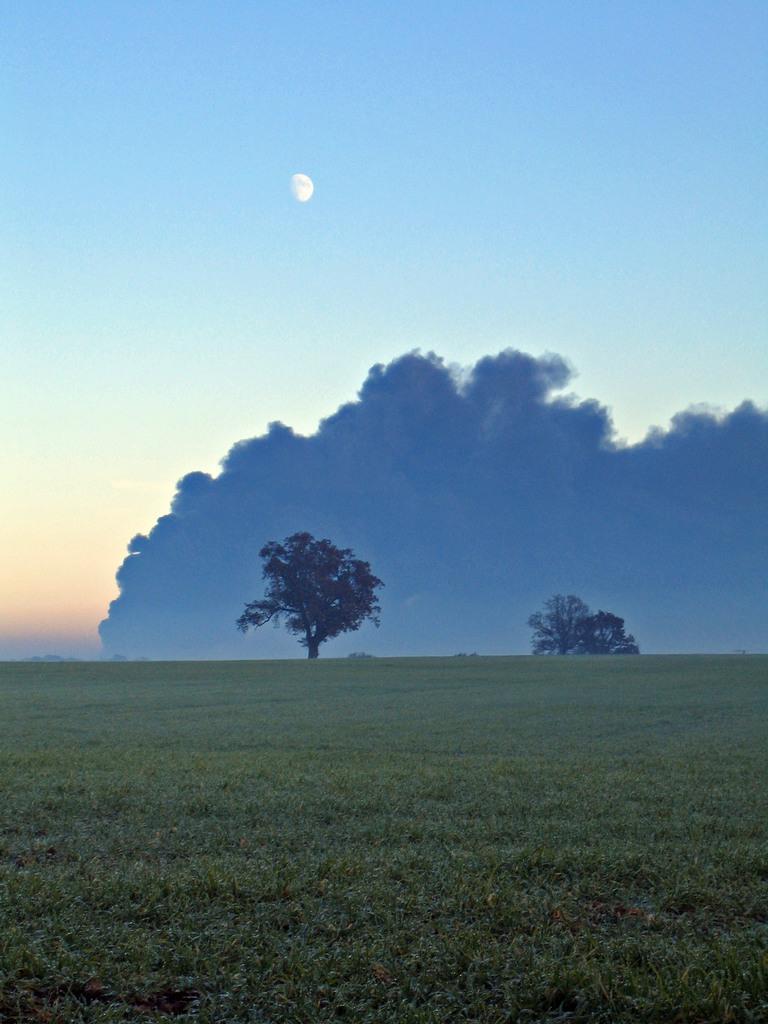Please provide a concise description of this image. In this image we can see the natural scenery of green grass and trees. Here we can see a moon and clouds in the sky. 